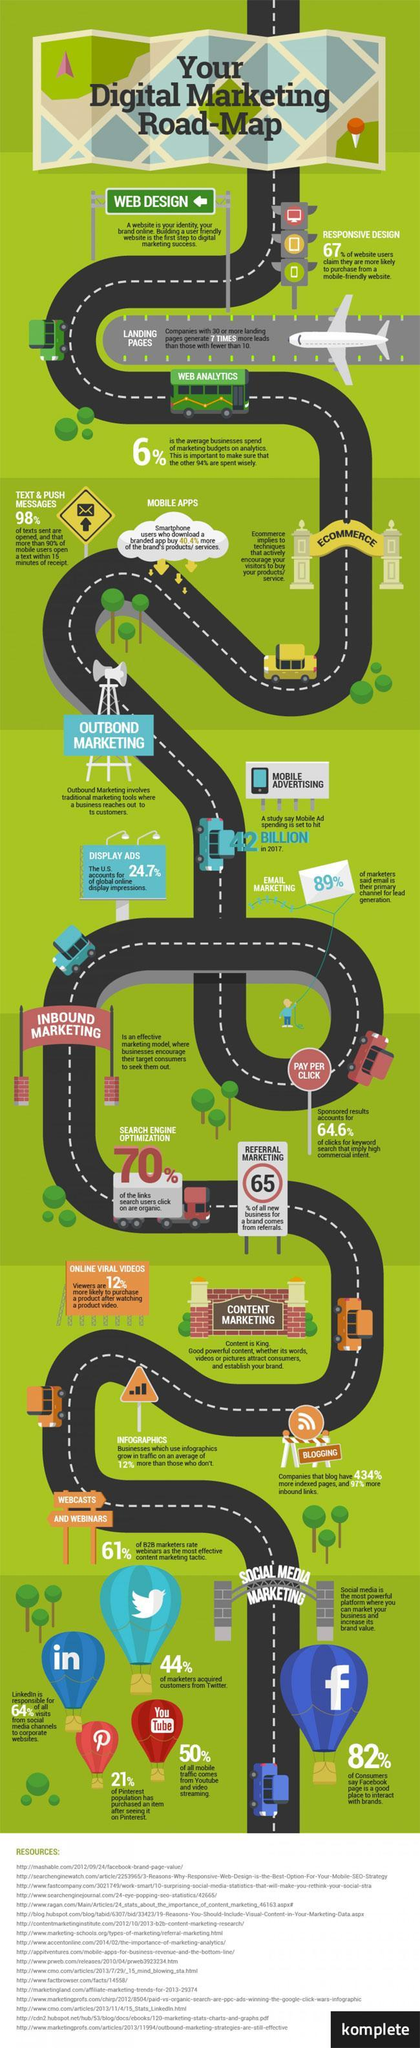Which  social media tool is used the most for social media marketing, Twitter, Linkedin, Pinterest, YouTube or Facebook?
Answer the question with a short phrase. Facebook Which category of marketing is Email marketing a part of? Outbound Marketing Under which category of marketing does content marketing fit in? Inbound Marketing Which are the three types of marketing? Outbound, Inbound, Social Media 